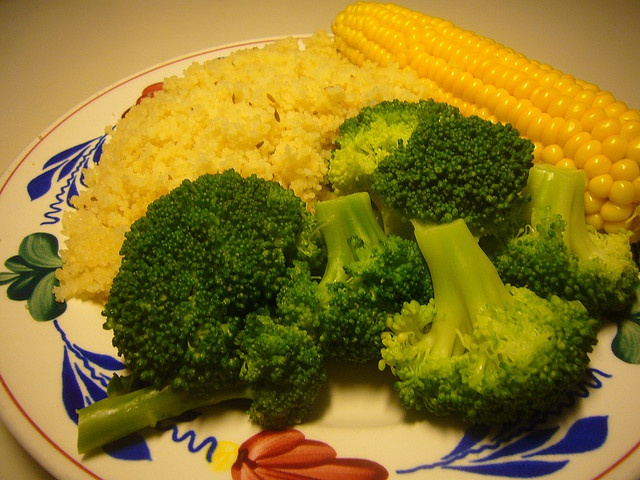Describe the objects in this image and their specific colors. I can see broccoli in olive, black, and darkgreen tones, broccoli in olive, black, and darkgreen tones, broccoli in olive, black, and darkgreen tones, broccoli in olive, black, and darkgreen tones, and broccoli in olive, black, and darkgreen tones in this image. 